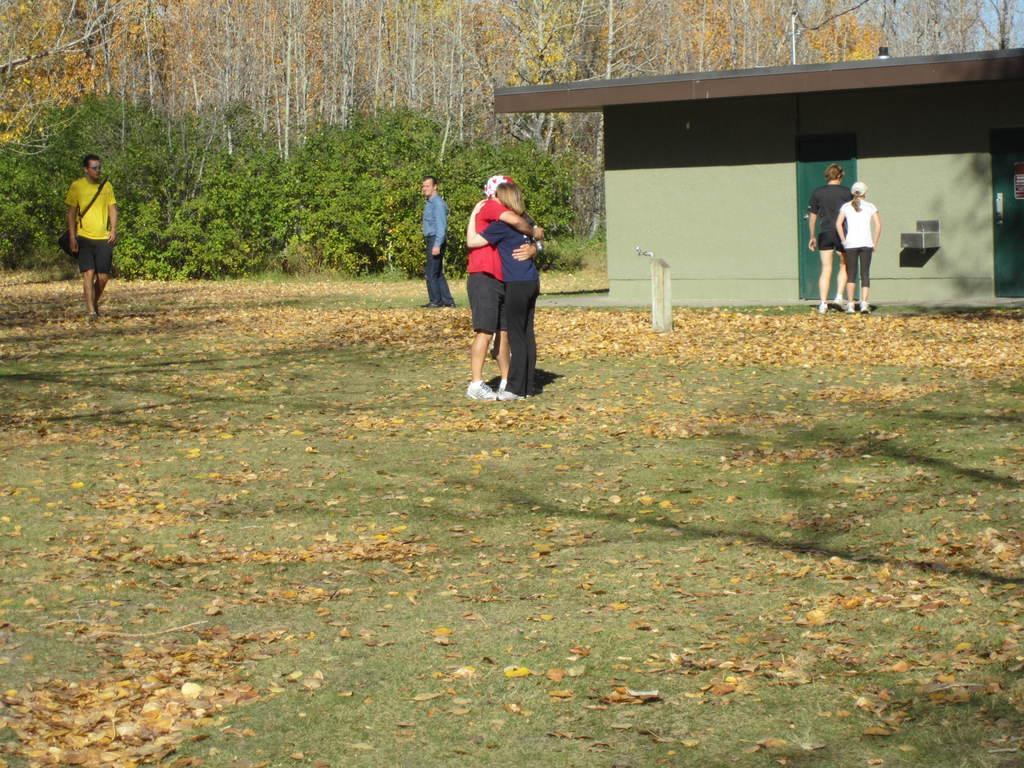Describe this image in one or two sentences. There is a person in red color t-shirt and a person in violet t-shirt, standing and hugging with each other on the grass on the ground. In the background, there are a person in yellow color t-shirt, walking on the grass on the ground, there is a person in shirt, standing, there are two persons walking near a building, there are plants, trees and clouds in the sky. 